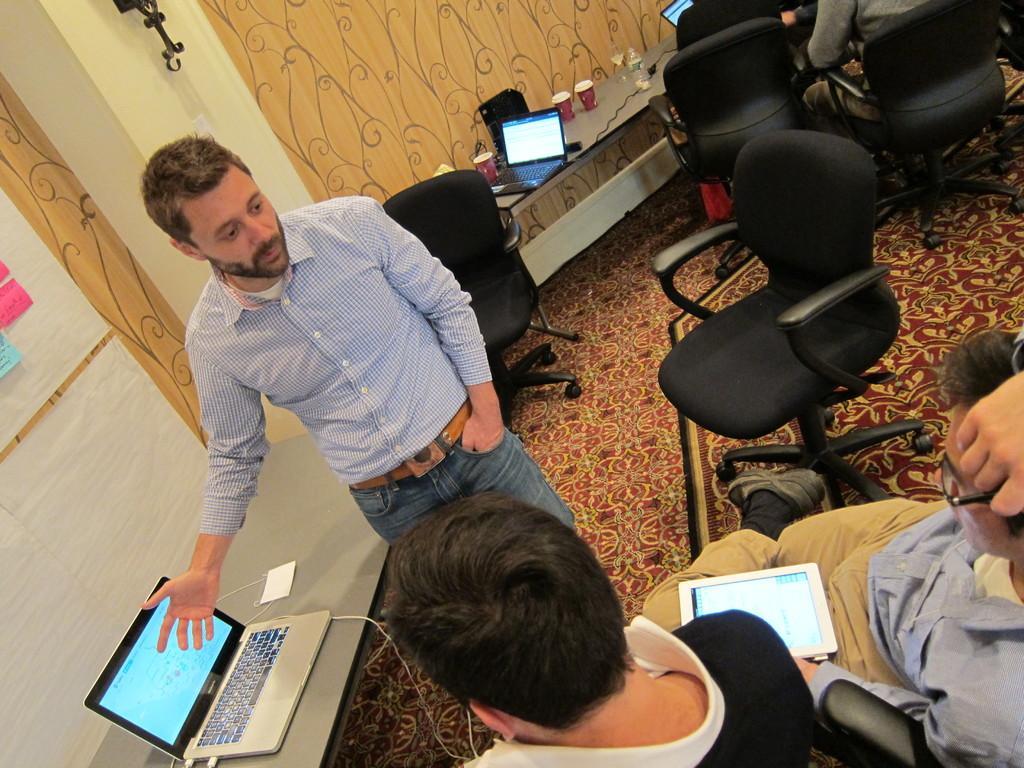Please provide a concise description of this image. In this picture we can see a man standing on the floor. These are the laptops on the table. And here we can see two persons sitting on the chairs. And this is the wall. 